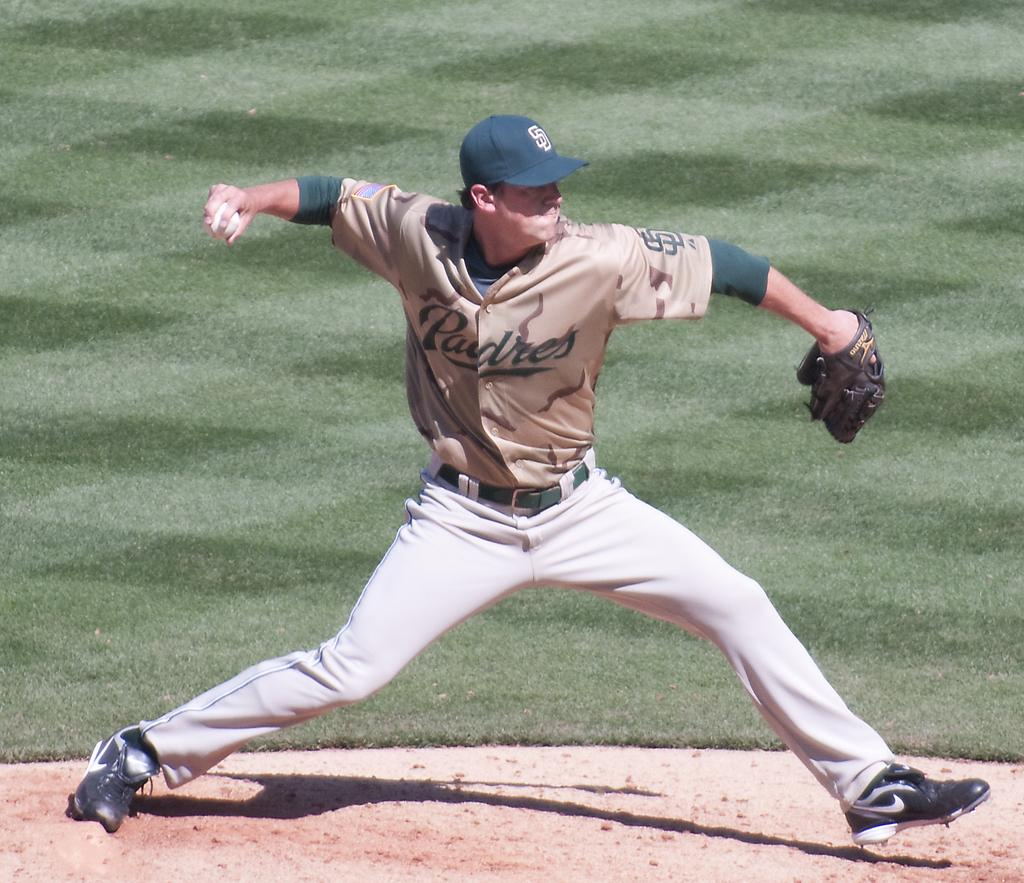<image>
Render a clear and concise summary of the photo. a baseball player that is on the Padres 